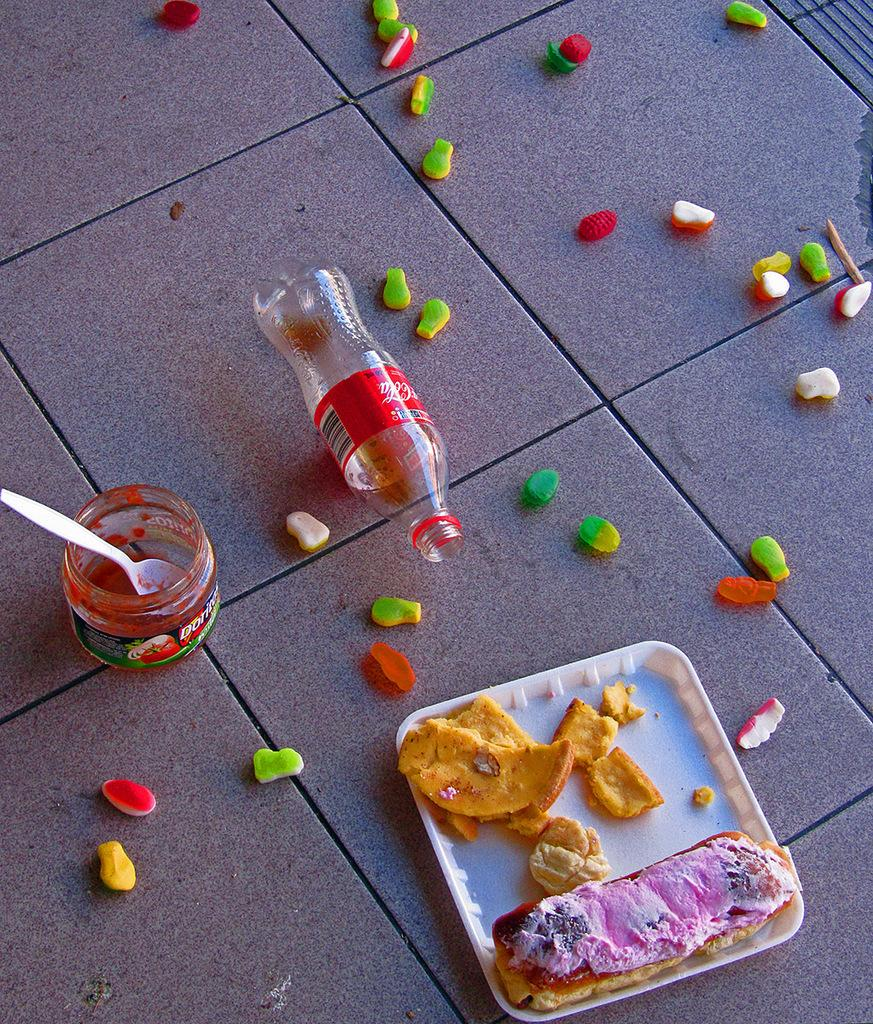What object is on the floor and appears to be empty? There is an empty bottle on the floor. What other objects are on the floor besides the empty bottle? There are cups, a spoon, a plate, and some food items on the floor. What might be used for stirring or eating in the image? The spoon on the floor might be used for stirring or eating. What type of watch is visible on the floor in the image? There is no watch present in the image. What game is being played on the floor in the image? There is no game being played in the image; it features an empty bottle, cups, a spoon, a plate, and food items on the floor. 